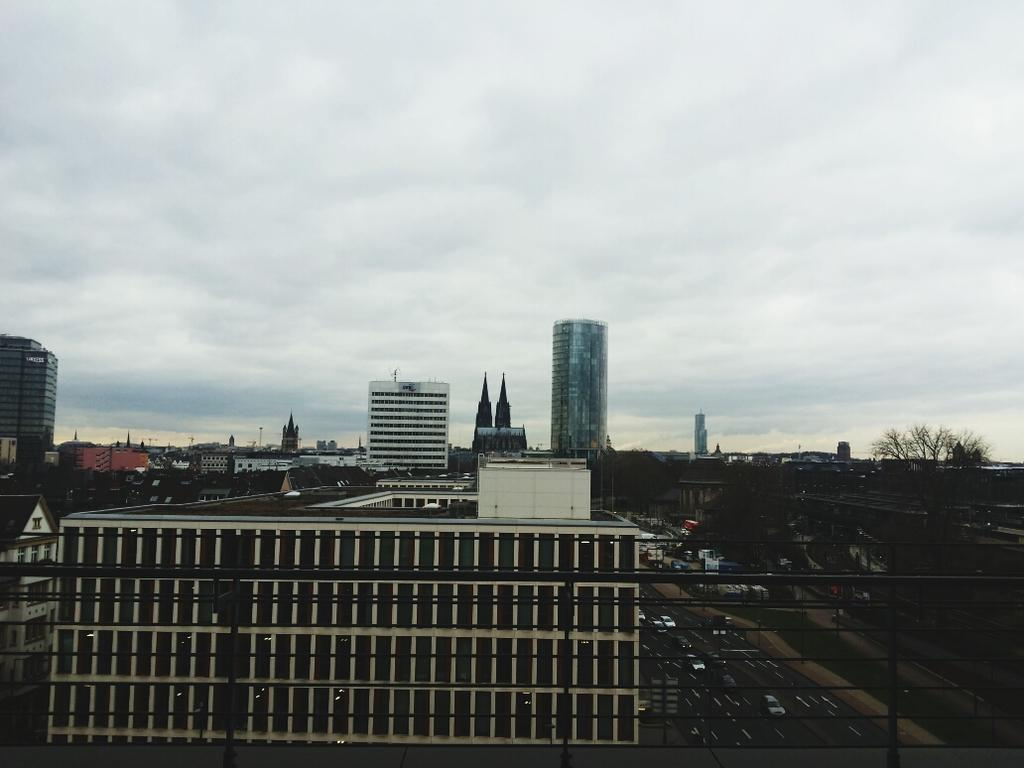What can be seen on the road in the image? There are many vehicles on the road in the image. What type of buildings are present in the image? There are white-colored buildings in the image. What natural elements can be seen in the background of the image? The background of the image includes trees. What is visible in the sky in the image? The sky is visible in the background of the image, and it appears to be white in color. Where is the park located in the image? There is no park present in the image. What type of brush is being used by the laborer in the image? There is no laborer or brush present in the image. 